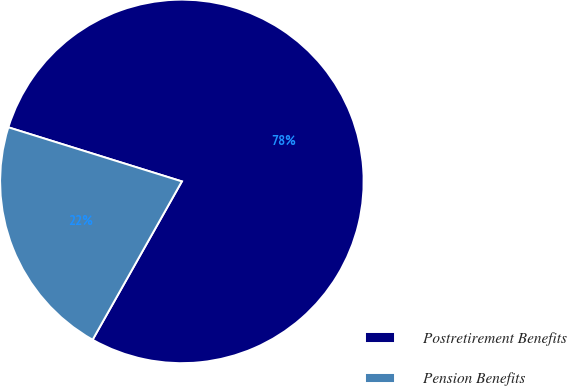Convert chart to OTSL. <chart><loc_0><loc_0><loc_500><loc_500><pie_chart><fcel>Postretirement Benefits<fcel>Pension Benefits<nl><fcel>78.36%<fcel>21.64%<nl></chart> 